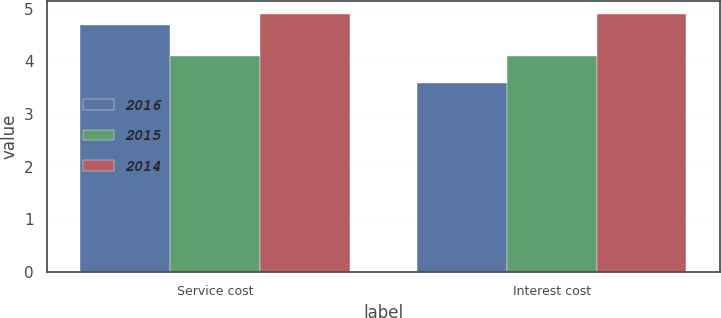Convert chart to OTSL. <chart><loc_0><loc_0><loc_500><loc_500><stacked_bar_chart><ecel><fcel>Service cost<fcel>Interest cost<nl><fcel>2016<fcel>4.7<fcel>3.6<nl><fcel>2015<fcel>4.1<fcel>4.1<nl><fcel>2014<fcel>4.9<fcel>4.9<nl></chart> 